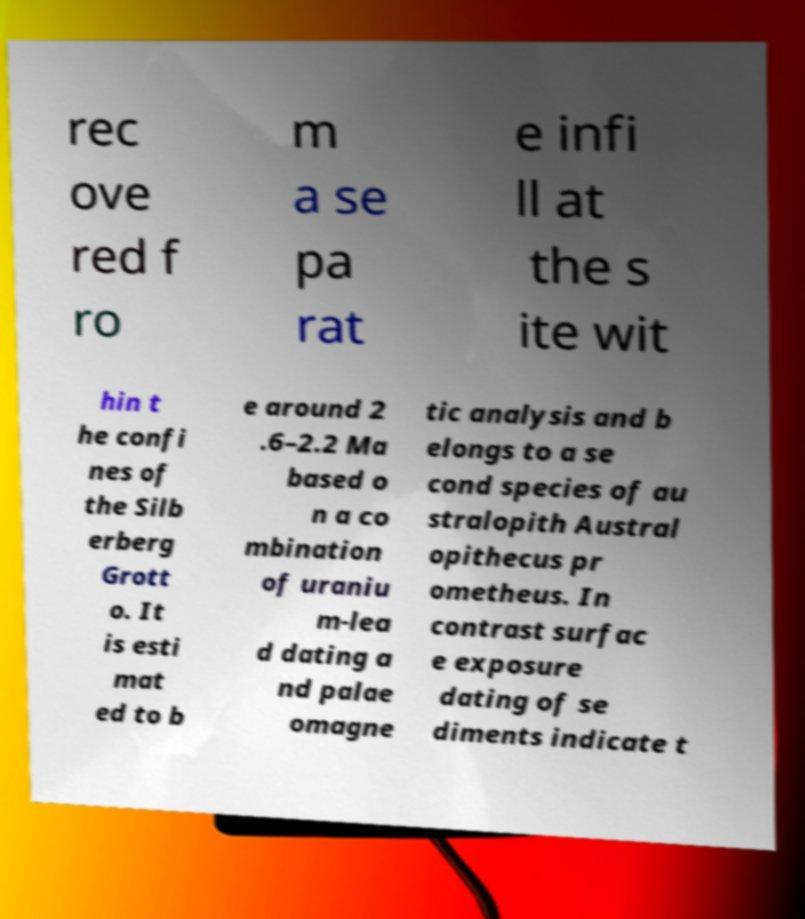For documentation purposes, I need the text within this image transcribed. Could you provide that? rec ove red f ro m a se pa rat e infi ll at the s ite wit hin t he confi nes of the Silb erberg Grott o. It is esti mat ed to b e around 2 .6–2.2 Ma based o n a co mbination of uraniu m-lea d dating a nd palae omagne tic analysis and b elongs to a se cond species of au stralopith Austral opithecus pr ometheus. In contrast surfac e exposure dating of se diments indicate t 